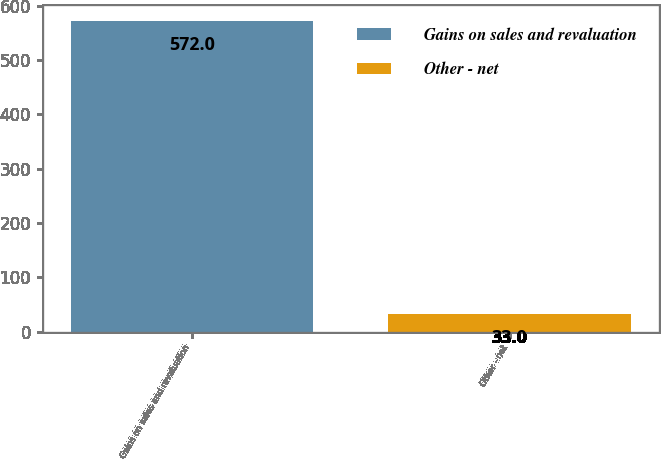Convert chart to OTSL. <chart><loc_0><loc_0><loc_500><loc_500><bar_chart><fcel>Gains on sales and revaluation<fcel>Other - net<nl><fcel>572<fcel>33<nl></chart> 